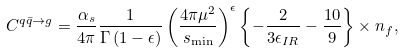<formula> <loc_0><loc_0><loc_500><loc_500>C ^ { q \bar { q } \to g } = \frac { \alpha _ { s } } { 4 \pi } \frac { 1 } { \Gamma \left ( 1 - \epsilon \right ) } \left ( \frac { 4 \pi \mu ^ { 2 } } { s _ { \min } } \right ) ^ { \epsilon } \left \{ - \frac { 2 } { 3 \epsilon _ { I R } } - \frac { 1 0 } { 9 } \right \} \times n _ { f } ,</formula> 